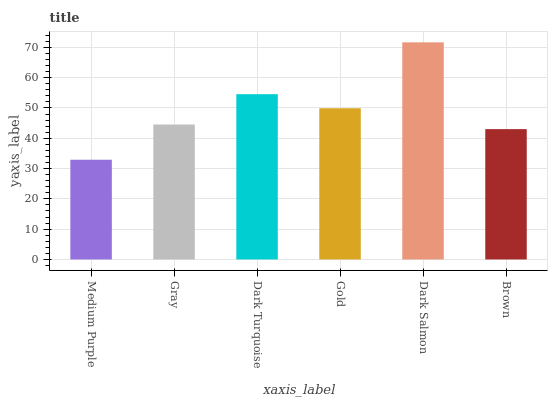Is Medium Purple the minimum?
Answer yes or no. Yes. Is Dark Salmon the maximum?
Answer yes or no. Yes. Is Gray the minimum?
Answer yes or no. No. Is Gray the maximum?
Answer yes or no. No. Is Gray greater than Medium Purple?
Answer yes or no. Yes. Is Medium Purple less than Gray?
Answer yes or no. Yes. Is Medium Purple greater than Gray?
Answer yes or no. No. Is Gray less than Medium Purple?
Answer yes or no. No. Is Gold the high median?
Answer yes or no. Yes. Is Gray the low median?
Answer yes or no. Yes. Is Medium Purple the high median?
Answer yes or no. No. Is Dark Turquoise the low median?
Answer yes or no. No. 